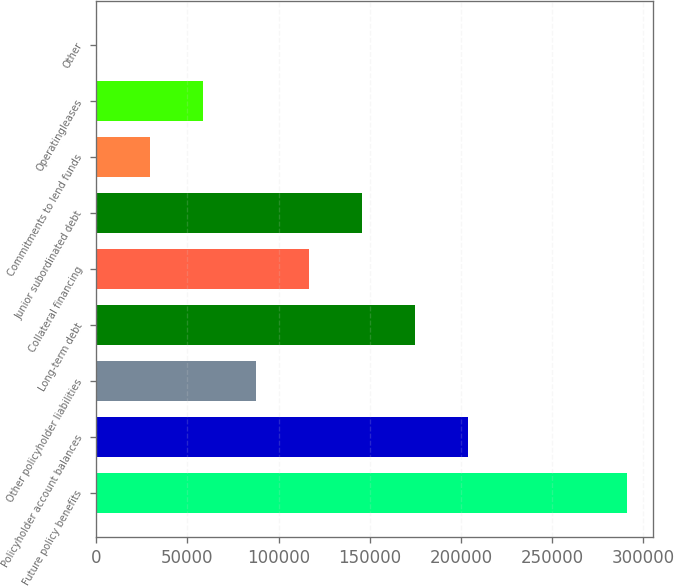Convert chart. <chart><loc_0><loc_0><loc_500><loc_500><bar_chart><fcel>Future policy benefits<fcel>Policyholder account balances<fcel>Other policyholder liabilities<fcel>Long-term debt<fcel>Collateral financing<fcel>Junior subordinated debt<fcel>Commitments to lend funds<fcel>Operatingleases<fcel>Other<nl><fcel>290794<fcel>203684<fcel>87537.8<fcel>174648<fcel>116574<fcel>145611<fcel>29464.6<fcel>58501.2<fcel>428<nl></chart> 